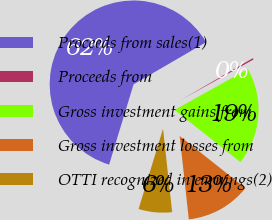<chart> <loc_0><loc_0><loc_500><loc_500><pie_chart><fcel>Proceeds from sales(1)<fcel>Proceeds from<fcel>Gross investment gains from<fcel>Gross investment losses from<fcel>OTTI recognized in earnings(2)<nl><fcel>61.91%<fcel>0.28%<fcel>18.77%<fcel>12.6%<fcel>6.44%<nl></chart> 